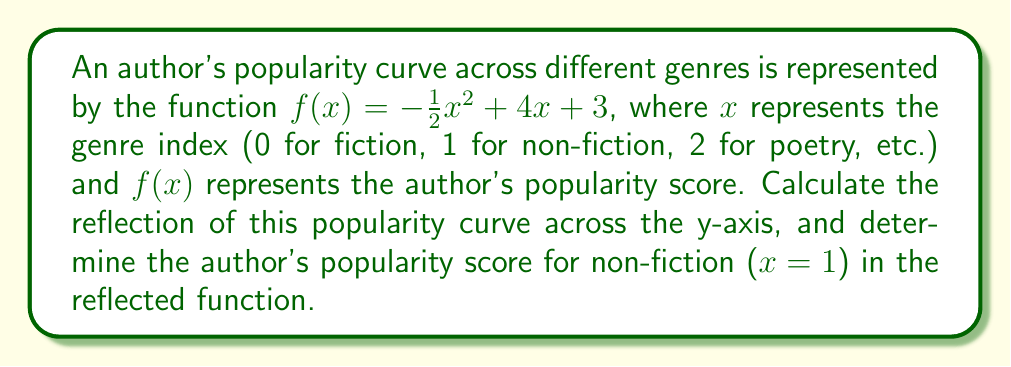Help me with this question. 1. To reflect a function across the y-axis, we replace every $x$ with $-x$ in the original function.

   Original function: $f(x) = -\frac{1}{2}x^2 + 4x + 3$
   Reflected function: $g(x) = -\frac{1}{2}(-x)^2 + 4(-x) + 3$

2. Simplify the reflected function:
   $g(x) = -\frac{1}{2}x^2 - 4x + 3$

3. To find the author's popularity score for non-fiction in the reflected function, we evaluate $g(1)$:

   $g(1) = -\frac{1}{2}(1)^2 - 4(1) + 3$
   $g(1) = -\frac{1}{2} - 4 + 3$
   $g(1) = -\frac{1}{2} - 1$
   $g(1) = -\frac{3}{2}$

4. Convert the fraction to a decimal:
   $g(1) = -1.5$

Therefore, the author's popularity score for non-fiction (x = 1) in the reflected function is -1.5.
Answer: -1.5 